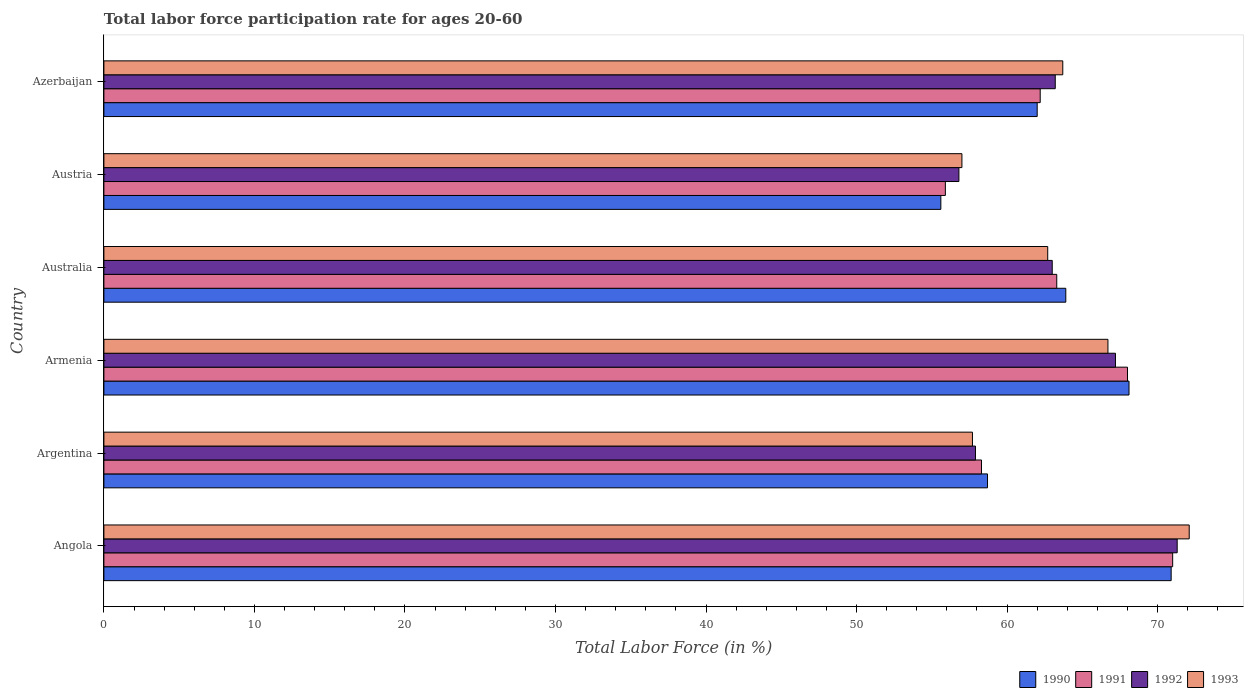How many different coloured bars are there?
Keep it short and to the point. 4. What is the label of the 6th group of bars from the top?
Your answer should be compact. Angola. In how many cases, is the number of bars for a given country not equal to the number of legend labels?
Provide a succinct answer. 0. What is the labor force participation rate in 1990 in Armenia?
Keep it short and to the point. 68.1. Across all countries, what is the maximum labor force participation rate in 1993?
Your answer should be compact. 72.1. In which country was the labor force participation rate in 1990 maximum?
Provide a succinct answer. Angola. In which country was the labor force participation rate in 1991 minimum?
Give a very brief answer. Austria. What is the total labor force participation rate in 1990 in the graph?
Your answer should be compact. 379.2. What is the difference between the labor force participation rate in 1991 in Armenia and that in Azerbaijan?
Ensure brevity in your answer.  5.8. What is the difference between the labor force participation rate in 1990 in Austria and the labor force participation rate in 1992 in Armenia?
Provide a succinct answer. -11.6. What is the average labor force participation rate in 1992 per country?
Offer a terse response. 63.23. What is the difference between the labor force participation rate in 1990 and labor force participation rate in 1991 in Angola?
Give a very brief answer. -0.1. In how many countries, is the labor force participation rate in 1992 greater than 16 %?
Your answer should be very brief. 6. What is the ratio of the labor force participation rate in 1990 in Armenia to that in Australia?
Provide a succinct answer. 1.07. Is the labor force participation rate in 1990 in Angola less than that in Azerbaijan?
Your answer should be very brief. No. What is the difference between the highest and the second highest labor force participation rate in 1990?
Provide a succinct answer. 2.8. What is the difference between the highest and the lowest labor force participation rate in 1993?
Your answer should be very brief. 15.1. Is the sum of the labor force participation rate in 1993 in Angola and Argentina greater than the maximum labor force participation rate in 1990 across all countries?
Your response must be concise. Yes. Is it the case that in every country, the sum of the labor force participation rate in 1992 and labor force participation rate in 1993 is greater than the sum of labor force participation rate in 1990 and labor force participation rate in 1991?
Ensure brevity in your answer.  No. What does the 4th bar from the top in Austria represents?
Your answer should be compact. 1990. What does the 3rd bar from the bottom in Azerbaijan represents?
Make the answer very short. 1992. How many bars are there?
Your answer should be compact. 24. Are the values on the major ticks of X-axis written in scientific E-notation?
Keep it short and to the point. No. Does the graph contain grids?
Offer a terse response. No. How are the legend labels stacked?
Make the answer very short. Horizontal. What is the title of the graph?
Offer a terse response. Total labor force participation rate for ages 20-60. What is the Total Labor Force (in %) in 1990 in Angola?
Offer a terse response. 70.9. What is the Total Labor Force (in %) of 1991 in Angola?
Keep it short and to the point. 71. What is the Total Labor Force (in %) in 1992 in Angola?
Your answer should be very brief. 71.3. What is the Total Labor Force (in %) of 1993 in Angola?
Provide a succinct answer. 72.1. What is the Total Labor Force (in %) in 1990 in Argentina?
Offer a very short reply. 58.7. What is the Total Labor Force (in %) in 1991 in Argentina?
Provide a succinct answer. 58.3. What is the Total Labor Force (in %) of 1992 in Argentina?
Your response must be concise. 57.9. What is the Total Labor Force (in %) of 1993 in Argentina?
Your response must be concise. 57.7. What is the Total Labor Force (in %) of 1990 in Armenia?
Your response must be concise. 68.1. What is the Total Labor Force (in %) in 1992 in Armenia?
Offer a very short reply. 67.2. What is the Total Labor Force (in %) in 1993 in Armenia?
Offer a very short reply. 66.7. What is the Total Labor Force (in %) in 1990 in Australia?
Give a very brief answer. 63.9. What is the Total Labor Force (in %) of 1991 in Australia?
Keep it short and to the point. 63.3. What is the Total Labor Force (in %) in 1992 in Australia?
Your answer should be compact. 63. What is the Total Labor Force (in %) in 1993 in Australia?
Offer a terse response. 62.7. What is the Total Labor Force (in %) in 1990 in Austria?
Keep it short and to the point. 55.6. What is the Total Labor Force (in %) in 1991 in Austria?
Provide a short and direct response. 55.9. What is the Total Labor Force (in %) of 1992 in Austria?
Your response must be concise. 56.8. What is the Total Labor Force (in %) of 1993 in Austria?
Keep it short and to the point. 57. What is the Total Labor Force (in %) of 1991 in Azerbaijan?
Provide a succinct answer. 62.2. What is the Total Labor Force (in %) in 1992 in Azerbaijan?
Make the answer very short. 63.2. What is the Total Labor Force (in %) in 1993 in Azerbaijan?
Make the answer very short. 63.7. Across all countries, what is the maximum Total Labor Force (in %) in 1990?
Provide a short and direct response. 70.9. Across all countries, what is the maximum Total Labor Force (in %) in 1991?
Ensure brevity in your answer.  71. Across all countries, what is the maximum Total Labor Force (in %) in 1992?
Offer a terse response. 71.3. Across all countries, what is the maximum Total Labor Force (in %) in 1993?
Offer a very short reply. 72.1. Across all countries, what is the minimum Total Labor Force (in %) in 1990?
Give a very brief answer. 55.6. Across all countries, what is the minimum Total Labor Force (in %) of 1991?
Offer a terse response. 55.9. Across all countries, what is the minimum Total Labor Force (in %) of 1992?
Provide a succinct answer. 56.8. Across all countries, what is the minimum Total Labor Force (in %) of 1993?
Your answer should be very brief. 57. What is the total Total Labor Force (in %) of 1990 in the graph?
Your answer should be compact. 379.2. What is the total Total Labor Force (in %) of 1991 in the graph?
Provide a short and direct response. 378.7. What is the total Total Labor Force (in %) of 1992 in the graph?
Keep it short and to the point. 379.4. What is the total Total Labor Force (in %) of 1993 in the graph?
Ensure brevity in your answer.  379.9. What is the difference between the Total Labor Force (in %) of 1991 in Angola and that in Argentina?
Offer a very short reply. 12.7. What is the difference between the Total Labor Force (in %) in 1992 in Angola and that in Argentina?
Offer a very short reply. 13.4. What is the difference between the Total Labor Force (in %) in 1990 in Angola and that in Armenia?
Make the answer very short. 2.8. What is the difference between the Total Labor Force (in %) of 1991 in Angola and that in Armenia?
Offer a terse response. 3. What is the difference between the Total Labor Force (in %) in 1990 in Angola and that in Australia?
Offer a terse response. 7. What is the difference between the Total Labor Force (in %) of 1991 in Angola and that in Australia?
Offer a very short reply. 7.7. What is the difference between the Total Labor Force (in %) in 1992 in Angola and that in Australia?
Keep it short and to the point. 8.3. What is the difference between the Total Labor Force (in %) in 1992 in Angola and that in Austria?
Offer a terse response. 14.5. What is the difference between the Total Labor Force (in %) in 1991 in Angola and that in Azerbaijan?
Provide a succinct answer. 8.8. What is the difference between the Total Labor Force (in %) of 1992 in Argentina and that in Armenia?
Offer a very short reply. -9.3. What is the difference between the Total Labor Force (in %) of 1990 in Argentina and that in Australia?
Give a very brief answer. -5.2. What is the difference between the Total Labor Force (in %) of 1991 in Argentina and that in Australia?
Keep it short and to the point. -5. What is the difference between the Total Labor Force (in %) of 1991 in Argentina and that in Austria?
Provide a succinct answer. 2.4. What is the difference between the Total Labor Force (in %) of 1992 in Argentina and that in Austria?
Make the answer very short. 1.1. What is the difference between the Total Labor Force (in %) in 1993 in Argentina and that in Austria?
Your response must be concise. 0.7. What is the difference between the Total Labor Force (in %) of 1990 in Argentina and that in Azerbaijan?
Your answer should be compact. -3.3. What is the difference between the Total Labor Force (in %) of 1991 in Argentina and that in Azerbaijan?
Your response must be concise. -3.9. What is the difference between the Total Labor Force (in %) of 1993 in Argentina and that in Azerbaijan?
Offer a terse response. -6. What is the difference between the Total Labor Force (in %) of 1992 in Armenia and that in Australia?
Your response must be concise. 4.2. What is the difference between the Total Labor Force (in %) in 1990 in Armenia and that in Austria?
Offer a very short reply. 12.5. What is the difference between the Total Labor Force (in %) of 1991 in Armenia and that in Austria?
Make the answer very short. 12.1. What is the difference between the Total Labor Force (in %) of 1992 in Armenia and that in Austria?
Provide a succinct answer. 10.4. What is the difference between the Total Labor Force (in %) of 1990 in Armenia and that in Azerbaijan?
Your answer should be compact. 6.1. What is the difference between the Total Labor Force (in %) in 1992 in Armenia and that in Azerbaijan?
Your answer should be compact. 4. What is the difference between the Total Labor Force (in %) of 1990 in Australia and that in Austria?
Ensure brevity in your answer.  8.3. What is the difference between the Total Labor Force (in %) in 1992 in Australia and that in Austria?
Make the answer very short. 6.2. What is the difference between the Total Labor Force (in %) of 1993 in Australia and that in Austria?
Offer a terse response. 5.7. What is the difference between the Total Labor Force (in %) in 1990 in Austria and that in Azerbaijan?
Offer a very short reply. -6.4. What is the difference between the Total Labor Force (in %) of 1991 in Austria and that in Azerbaijan?
Provide a short and direct response. -6.3. What is the difference between the Total Labor Force (in %) in 1992 in Austria and that in Azerbaijan?
Make the answer very short. -6.4. What is the difference between the Total Labor Force (in %) in 1990 in Angola and the Total Labor Force (in %) in 1992 in Argentina?
Make the answer very short. 13. What is the difference between the Total Labor Force (in %) of 1992 in Angola and the Total Labor Force (in %) of 1993 in Argentina?
Keep it short and to the point. 13.6. What is the difference between the Total Labor Force (in %) in 1990 in Angola and the Total Labor Force (in %) in 1992 in Armenia?
Your answer should be compact. 3.7. What is the difference between the Total Labor Force (in %) of 1992 in Angola and the Total Labor Force (in %) of 1993 in Armenia?
Your response must be concise. 4.6. What is the difference between the Total Labor Force (in %) in 1990 in Angola and the Total Labor Force (in %) in 1993 in Australia?
Offer a very short reply. 8.2. What is the difference between the Total Labor Force (in %) in 1991 in Angola and the Total Labor Force (in %) in 1993 in Australia?
Make the answer very short. 8.3. What is the difference between the Total Labor Force (in %) in 1990 in Angola and the Total Labor Force (in %) in 1991 in Austria?
Ensure brevity in your answer.  15. What is the difference between the Total Labor Force (in %) in 1990 in Angola and the Total Labor Force (in %) in 1992 in Austria?
Your answer should be compact. 14.1. What is the difference between the Total Labor Force (in %) in 1991 in Angola and the Total Labor Force (in %) in 1993 in Austria?
Provide a succinct answer. 14. What is the difference between the Total Labor Force (in %) of 1992 in Angola and the Total Labor Force (in %) of 1993 in Austria?
Your answer should be compact. 14.3. What is the difference between the Total Labor Force (in %) in 1990 in Angola and the Total Labor Force (in %) in 1991 in Azerbaijan?
Keep it short and to the point. 8.7. What is the difference between the Total Labor Force (in %) in 1990 in Angola and the Total Labor Force (in %) in 1992 in Azerbaijan?
Give a very brief answer. 7.7. What is the difference between the Total Labor Force (in %) of 1991 in Angola and the Total Labor Force (in %) of 1992 in Azerbaijan?
Your answer should be compact. 7.8. What is the difference between the Total Labor Force (in %) in 1991 in Angola and the Total Labor Force (in %) in 1993 in Azerbaijan?
Make the answer very short. 7.3. What is the difference between the Total Labor Force (in %) of 1992 in Angola and the Total Labor Force (in %) of 1993 in Azerbaijan?
Provide a succinct answer. 7.6. What is the difference between the Total Labor Force (in %) of 1990 in Argentina and the Total Labor Force (in %) of 1991 in Armenia?
Your answer should be very brief. -9.3. What is the difference between the Total Labor Force (in %) of 1991 in Argentina and the Total Labor Force (in %) of 1992 in Armenia?
Ensure brevity in your answer.  -8.9. What is the difference between the Total Labor Force (in %) in 1991 in Argentina and the Total Labor Force (in %) in 1993 in Armenia?
Give a very brief answer. -8.4. What is the difference between the Total Labor Force (in %) of 1992 in Argentina and the Total Labor Force (in %) of 1993 in Armenia?
Give a very brief answer. -8.8. What is the difference between the Total Labor Force (in %) in 1990 in Argentina and the Total Labor Force (in %) in 1992 in Australia?
Your answer should be very brief. -4.3. What is the difference between the Total Labor Force (in %) of 1990 in Argentina and the Total Labor Force (in %) of 1993 in Australia?
Make the answer very short. -4. What is the difference between the Total Labor Force (in %) in 1991 in Argentina and the Total Labor Force (in %) in 1992 in Australia?
Your response must be concise. -4.7. What is the difference between the Total Labor Force (in %) of 1991 in Argentina and the Total Labor Force (in %) of 1993 in Australia?
Make the answer very short. -4.4. What is the difference between the Total Labor Force (in %) of 1991 in Argentina and the Total Labor Force (in %) of 1992 in Austria?
Provide a succinct answer. 1.5. What is the difference between the Total Labor Force (in %) of 1991 in Argentina and the Total Labor Force (in %) of 1993 in Austria?
Offer a very short reply. 1.3. What is the difference between the Total Labor Force (in %) of 1990 in Argentina and the Total Labor Force (in %) of 1991 in Azerbaijan?
Your answer should be very brief. -3.5. What is the difference between the Total Labor Force (in %) in 1990 in Argentina and the Total Labor Force (in %) in 1993 in Azerbaijan?
Offer a very short reply. -5. What is the difference between the Total Labor Force (in %) of 1991 in Argentina and the Total Labor Force (in %) of 1992 in Azerbaijan?
Provide a short and direct response. -4.9. What is the difference between the Total Labor Force (in %) of 1991 in Argentina and the Total Labor Force (in %) of 1993 in Azerbaijan?
Make the answer very short. -5.4. What is the difference between the Total Labor Force (in %) in 1992 in Argentina and the Total Labor Force (in %) in 1993 in Azerbaijan?
Offer a very short reply. -5.8. What is the difference between the Total Labor Force (in %) of 1990 in Armenia and the Total Labor Force (in %) of 1993 in Australia?
Offer a very short reply. 5.4. What is the difference between the Total Labor Force (in %) in 1991 in Armenia and the Total Labor Force (in %) in 1992 in Australia?
Your answer should be very brief. 5. What is the difference between the Total Labor Force (in %) in 1991 in Armenia and the Total Labor Force (in %) in 1993 in Australia?
Make the answer very short. 5.3. What is the difference between the Total Labor Force (in %) of 1992 in Armenia and the Total Labor Force (in %) of 1993 in Australia?
Give a very brief answer. 4.5. What is the difference between the Total Labor Force (in %) of 1990 in Armenia and the Total Labor Force (in %) of 1991 in Austria?
Make the answer very short. 12.2. What is the difference between the Total Labor Force (in %) in 1990 in Armenia and the Total Labor Force (in %) in 1992 in Austria?
Ensure brevity in your answer.  11.3. What is the difference between the Total Labor Force (in %) in 1991 in Armenia and the Total Labor Force (in %) in 1992 in Austria?
Provide a succinct answer. 11.2. What is the difference between the Total Labor Force (in %) in 1992 in Armenia and the Total Labor Force (in %) in 1993 in Austria?
Your response must be concise. 10.2. What is the difference between the Total Labor Force (in %) in 1990 in Armenia and the Total Labor Force (in %) in 1991 in Azerbaijan?
Make the answer very short. 5.9. What is the difference between the Total Labor Force (in %) in 1990 in Armenia and the Total Labor Force (in %) in 1992 in Azerbaijan?
Ensure brevity in your answer.  4.9. What is the difference between the Total Labor Force (in %) of 1991 in Armenia and the Total Labor Force (in %) of 1992 in Azerbaijan?
Your response must be concise. 4.8. What is the difference between the Total Labor Force (in %) of 1992 in Armenia and the Total Labor Force (in %) of 1993 in Azerbaijan?
Keep it short and to the point. 3.5. What is the difference between the Total Labor Force (in %) of 1990 in Australia and the Total Labor Force (in %) of 1993 in Austria?
Your response must be concise. 6.9. What is the difference between the Total Labor Force (in %) in 1991 in Australia and the Total Labor Force (in %) in 1993 in Austria?
Give a very brief answer. 6.3. What is the difference between the Total Labor Force (in %) in 1992 in Australia and the Total Labor Force (in %) in 1993 in Austria?
Offer a very short reply. 6. What is the difference between the Total Labor Force (in %) in 1990 in Australia and the Total Labor Force (in %) in 1991 in Azerbaijan?
Provide a short and direct response. 1.7. What is the difference between the Total Labor Force (in %) of 1990 in Australia and the Total Labor Force (in %) of 1993 in Azerbaijan?
Offer a terse response. 0.2. What is the difference between the Total Labor Force (in %) of 1991 in Australia and the Total Labor Force (in %) of 1992 in Azerbaijan?
Provide a short and direct response. 0.1. What is the difference between the Total Labor Force (in %) of 1991 in Australia and the Total Labor Force (in %) of 1993 in Azerbaijan?
Your answer should be compact. -0.4. What is the difference between the Total Labor Force (in %) in 1992 in Australia and the Total Labor Force (in %) in 1993 in Azerbaijan?
Your answer should be compact. -0.7. What is the difference between the Total Labor Force (in %) in 1990 in Austria and the Total Labor Force (in %) in 1992 in Azerbaijan?
Provide a short and direct response. -7.6. What is the difference between the Total Labor Force (in %) in 1991 in Austria and the Total Labor Force (in %) in 1992 in Azerbaijan?
Ensure brevity in your answer.  -7.3. What is the average Total Labor Force (in %) in 1990 per country?
Provide a succinct answer. 63.2. What is the average Total Labor Force (in %) of 1991 per country?
Offer a terse response. 63.12. What is the average Total Labor Force (in %) of 1992 per country?
Provide a short and direct response. 63.23. What is the average Total Labor Force (in %) of 1993 per country?
Provide a succinct answer. 63.32. What is the difference between the Total Labor Force (in %) of 1990 and Total Labor Force (in %) of 1992 in Angola?
Your response must be concise. -0.4. What is the difference between the Total Labor Force (in %) in 1991 and Total Labor Force (in %) in 1993 in Angola?
Your response must be concise. -1.1. What is the difference between the Total Labor Force (in %) of 1990 and Total Labor Force (in %) of 1992 in Argentina?
Ensure brevity in your answer.  0.8. What is the difference between the Total Labor Force (in %) of 1991 and Total Labor Force (in %) of 1993 in Argentina?
Give a very brief answer. 0.6. What is the difference between the Total Labor Force (in %) of 1992 and Total Labor Force (in %) of 1993 in Argentina?
Ensure brevity in your answer.  0.2. What is the difference between the Total Labor Force (in %) of 1990 and Total Labor Force (in %) of 1991 in Armenia?
Provide a succinct answer. 0.1. What is the difference between the Total Labor Force (in %) in 1990 and Total Labor Force (in %) in 1992 in Armenia?
Keep it short and to the point. 0.9. What is the difference between the Total Labor Force (in %) in 1990 and Total Labor Force (in %) in 1993 in Armenia?
Offer a terse response. 1.4. What is the difference between the Total Labor Force (in %) in 1991 and Total Labor Force (in %) in 1993 in Armenia?
Provide a short and direct response. 1.3. What is the difference between the Total Labor Force (in %) in 1992 and Total Labor Force (in %) in 1993 in Armenia?
Ensure brevity in your answer.  0.5. What is the difference between the Total Labor Force (in %) of 1990 and Total Labor Force (in %) of 1993 in Australia?
Your response must be concise. 1.2. What is the difference between the Total Labor Force (in %) in 1991 and Total Labor Force (in %) in 1993 in Australia?
Provide a succinct answer. 0.6. What is the difference between the Total Labor Force (in %) of 1992 and Total Labor Force (in %) of 1993 in Australia?
Ensure brevity in your answer.  0.3. What is the difference between the Total Labor Force (in %) of 1990 and Total Labor Force (in %) of 1992 in Austria?
Give a very brief answer. -1.2. What is the difference between the Total Labor Force (in %) of 1991 and Total Labor Force (in %) of 1992 in Austria?
Make the answer very short. -0.9. What is the difference between the Total Labor Force (in %) in 1992 and Total Labor Force (in %) in 1993 in Austria?
Your answer should be very brief. -0.2. What is the difference between the Total Labor Force (in %) of 1990 and Total Labor Force (in %) of 1991 in Azerbaijan?
Make the answer very short. -0.2. What is the difference between the Total Labor Force (in %) of 1990 and Total Labor Force (in %) of 1993 in Azerbaijan?
Ensure brevity in your answer.  -1.7. What is the ratio of the Total Labor Force (in %) of 1990 in Angola to that in Argentina?
Provide a short and direct response. 1.21. What is the ratio of the Total Labor Force (in %) of 1991 in Angola to that in Argentina?
Offer a very short reply. 1.22. What is the ratio of the Total Labor Force (in %) in 1992 in Angola to that in Argentina?
Your answer should be very brief. 1.23. What is the ratio of the Total Labor Force (in %) in 1993 in Angola to that in Argentina?
Provide a short and direct response. 1.25. What is the ratio of the Total Labor Force (in %) of 1990 in Angola to that in Armenia?
Keep it short and to the point. 1.04. What is the ratio of the Total Labor Force (in %) in 1991 in Angola to that in Armenia?
Keep it short and to the point. 1.04. What is the ratio of the Total Labor Force (in %) in 1992 in Angola to that in Armenia?
Give a very brief answer. 1.06. What is the ratio of the Total Labor Force (in %) of 1993 in Angola to that in Armenia?
Your answer should be compact. 1.08. What is the ratio of the Total Labor Force (in %) in 1990 in Angola to that in Australia?
Offer a very short reply. 1.11. What is the ratio of the Total Labor Force (in %) in 1991 in Angola to that in Australia?
Offer a very short reply. 1.12. What is the ratio of the Total Labor Force (in %) of 1992 in Angola to that in Australia?
Your answer should be compact. 1.13. What is the ratio of the Total Labor Force (in %) of 1993 in Angola to that in Australia?
Your response must be concise. 1.15. What is the ratio of the Total Labor Force (in %) of 1990 in Angola to that in Austria?
Keep it short and to the point. 1.28. What is the ratio of the Total Labor Force (in %) of 1991 in Angola to that in Austria?
Make the answer very short. 1.27. What is the ratio of the Total Labor Force (in %) in 1992 in Angola to that in Austria?
Give a very brief answer. 1.26. What is the ratio of the Total Labor Force (in %) of 1993 in Angola to that in Austria?
Make the answer very short. 1.26. What is the ratio of the Total Labor Force (in %) of 1990 in Angola to that in Azerbaijan?
Your answer should be compact. 1.14. What is the ratio of the Total Labor Force (in %) in 1991 in Angola to that in Azerbaijan?
Offer a very short reply. 1.14. What is the ratio of the Total Labor Force (in %) of 1992 in Angola to that in Azerbaijan?
Offer a very short reply. 1.13. What is the ratio of the Total Labor Force (in %) in 1993 in Angola to that in Azerbaijan?
Ensure brevity in your answer.  1.13. What is the ratio of the Total Labor Force (in %) of 1990 in Argentina to that in Armenia?
Offer a terse response. 0.86. What is the ratio of the Total Labor Force (in %) of 1991 in Argentina to that in Armenia?
Keep it short and to the point. 0.86. What is the ratio of the Total Labor Force (in %) in 1992 in Argentina to that in Armenia?
Your answer should be very brief. 0.86. What is the ratio of the Total Labor Force (in %) of 1993 in Argentina to that in Armenia?
Keep it short and to the point. 0.87. What is the ratio of the Total Labor Force (in %) of 1990 in Argentina to that in Australia?
Ensure brevity in your answer.  0.92. What is the ratio of the Total Labor Force (in %) in 1991 in Argentina to that in Australia?
Your response must be concise. 0.92. What is the ratio of the Total Labor Force (in %) in 1992 in Argentina to that in Australia?
Provide a succinct answer. 0.92. What is the ratio of the Total Labor Force (in %) of 1993 in Argentina to that in Australia?
Provide a succinct answer. 0.92. What is the ratio of the Total Labor Force (in %) in 1990 in Argentina to that in Austria?
Your response must be concise. 1.06. What is the ratio of the Total Labor Force (in %) of 1991 in Argentina to that in Austria?
Keep it short and to the point. 1.04. What is the ratio of the Total Labor Force (in %) of 1992 in Argentina to that in Austria?
Offer a terse response. 1.02. What is the ratio of the Total Labor Force (in %) in 1993 in Argentina to that in Austria?
Offer a terse response. 1.01. What is the ratio of the Total Labor Force (in %) in 1990 in Argentina to that in Azerbaijan?
Give a very brief answer. 0.95. What is the ratio of the Total Labor Force (in %) of 1991 in Argentina to that in Azerbaijan?
Your answer should be compact. 0.94. What is the ratio of the Total Labor Force (in %) of 1992 in Argentina to that in Azerbaijan?
Give a very brief answer. 0.92. What is the ratio of the Total Labor Force (in %) in 1993 in Argentina to that in Azerbaijan?
Give a very brief answer. 0.91. What is the ratio of the Total Labor Force (in %) of 1990 in Armenia to that in Australia?
Your response must be concise. 1.07. What is the ratio of the Total Labor Force (in %) of 1991 in Armenia to that in Australia?
Offer a terse response. 1.07. What is the ratio of the Total Labor Force (in %) in 1992 in Armenia to that in Australia?
Provide a short and direct response. 1.07. What is the ratio of the Total Labor Force (in %) of 1993 in Armenia to that in Australia?
Offer a very short reply. 1.06. What is the ratio of the Total Labor Force (in %) of 1990 in Armenia to that in Austria?
Offer a terse response. 1.22. What is the ratio of the Total Labor Force (in %) in 1991 in Armenia to that in Austria?
Keep it short and to the point. 1.22. What is the ratio of the Total Labor Force (in %) of 1992 in Armenia to that in Austria?
Your answer should be compact. 1.18. What is the ratio of the Total Labor Force (in %) in 1993 in Armenia to that in Austria?
Make the answer very short. 1.17. What is the ratio of the Total Labor Force (in %) in 1990 in Armenia to that in Azerbaijan?
Keep it short and to the point. 1.1. What is the ratio of the Total Labor Force (in %) of 1991 in Armenia to that in Azerbaijan?
Offer a terse response. 1.09. What is the ratio of the Total Labor Force (in %) in 1992 in Armenia to that in Azerbaijan?
Your answer should be very brief. 1.06. What is the ratio of the Total Labor Force (in %) of 1993 in Armenia to that in Azerbaijan?
Your answer should be very brief. 1.05. What is the ratio of the Total Labor Force (in %) in 1990 in Australia to that in Austria?
Your answer should be compact. 1.15. What is the ratio of the Total Labor Force (in %) in 1991 in Australia to that in Austria?
Ensure brevity in your answer.  1.13. What is the ratio of the Total Labor Force (in %) of 1992 in Australia to that in Austria?
Your answer should be very brief. 1.11. What is the ratio of the Total Labor Force (in %) of 1993 in Australia to that in Austria?
Offer a very short reply. 1.1. What is the ratio of the Total Labor Force (in %) in 1990 in Australia to that in Azerbaijan?
Ensure brevity in your answer.  1.03. What is the ratio of the Total Labor Force (in %) of 1991 in Australia to that in Azerbaijan?
Your answer should be very brief. 1.02. What is the ratio of the Total Labor Force (in %) in 1993 in Australia to that in Azerbaijan?
Provide a short and direct response. 0.98. What is the ratio of the Total Labor Force (in %) in 1990 in Austria to that in Azerbaijan?
Ensure brevity in your answer.  0.9. What is the ratio of the Total Labor Force (in %) in 1991 in Austria to that in Azerbaijan?
Your answer should be very brief. 0.9. What is the ratio of the Total Labor Force (in %) of 1992 in Austria to that in Azerbaijan?
Give a very brief answer. 0.9. What is the ratio of the Total Labor Force (in %) of 1993 in Austria to that in Azerbaijan?
Provide a short and direct response. 0.89. What is the difference between the highest and the second highest Total Labor Force (in %) in 1990?
Your answer should be very brief. 2.8. What is the difference between the highest and the lowest Total Labor Force (in %) of 1990?
Ensure brevity in your answer.  15.3. What is the difference between the highest and the lowest Total Labor Force (in %) of 1992?
Your answer should be very brief. 14.5. What is the difference between the highest and the lowest Total Labor Force (in %) in 1993?
Provide a succinct answer. 15.1. 